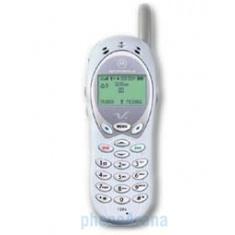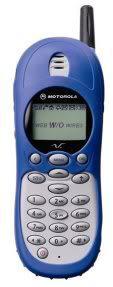The first image is the image on the left, the second image is the image on the right. Assess this claim about the two images: "A flip phone is in the open position in the image on the right.". Correct or not? Answer yes or no. No. The first image is the image on the left, the second image is the image on the right. Evaluate the accuracy of this statement regarding the images: "The left image features a phone style that does not flip up and has a short antenna on the top and a rectangular display on the front, and the right image includes a phone with its lid flipped up.". Is it true? Answer yes or no. No. 